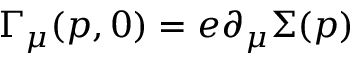<formula> <loc_0><loc_0><loc_500><loc_500>\Gamma _ { \mu } ( p , 0 ) = e \partial _ { \mu } \Sigma ( p )</formula> 